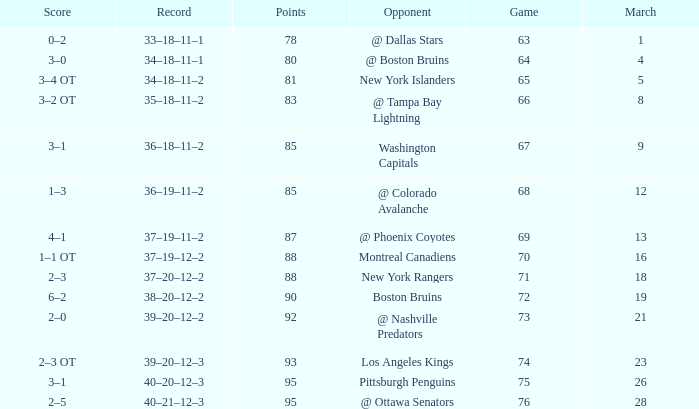Which Points have an Opponent of new york islanders, and a Game smaller than 65? None. 